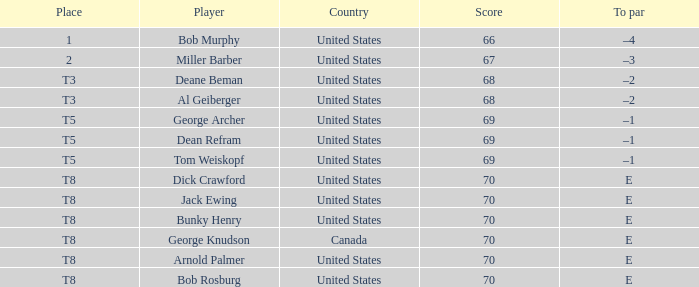When bunky henry of the united states got more than 67 and his to par was e, what was his ranking? T8. 